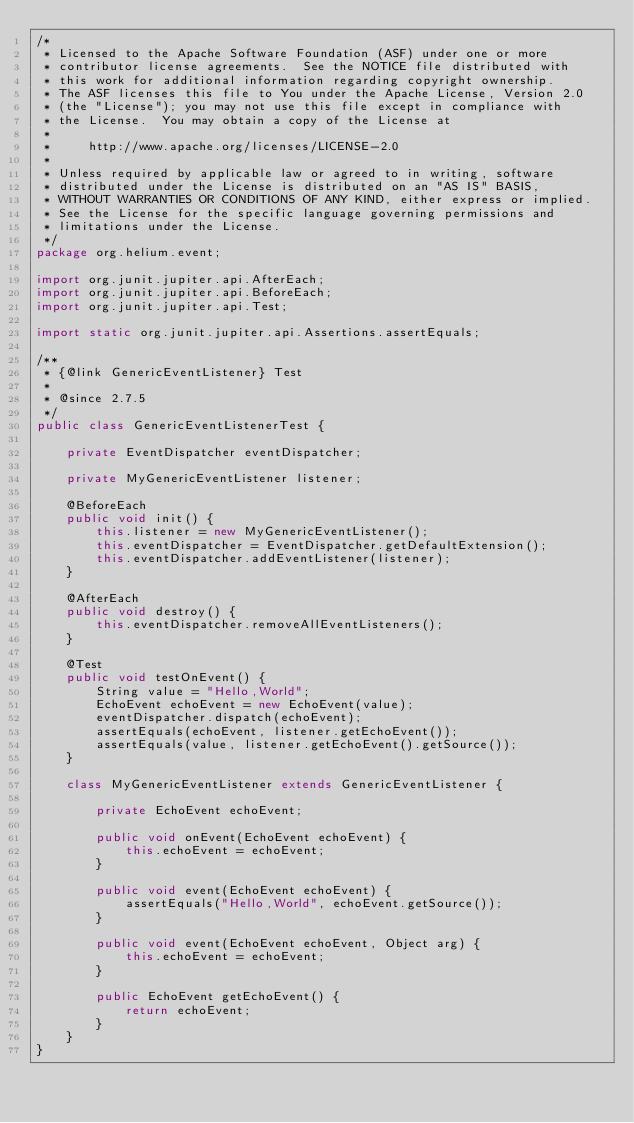Convert code to text. <code><loc_0><loc_0><loc_500><loc_500><_Java_>/*
 * Licensed to the Apache Software Foundation (ASF) under one or more
 * contributor license agreements.  See the NOTICE file distributed with
 * this work for additional information regarding copyright ownership.
 * The ASF licenses this file to You under the Apache License, Version 2.0
 * (the "License"); you may not use this file except in compliance with
 * the License.  You may obtain a copy of the License at
 *
 *     http://www.apache.org/licenses/LICENSE-2.0
 *
 * Unless required by applicable law or agreed to in writing, software
 * distributed under the License is distributed on an "AS IS" BASIS,
 * WITHOUT WARRANTIES OR CONDITIONS OF ANY KIND, either express or implied.
 * See the License for the specific language governing permissions and
 * limitations under the License.
 */
package org.helium.event;

import org.junit.jupiter.api.AfterEach;
import org.junit.jupiter.api.BeforeEach;
import org.junit.jupiter.api.Test;

import static org.junit.jupiter.api.Assertions.assertEquals;

/**
 * {@link GenericEventListener} Test
 *
 * @since 2.7.5
 */
public class GenericEventListenerTest {

    private EventDispatcher eventDispatcher;

    private MyGenericEventListener listener;

    @BeforeEach
    public void init() {
        this.listener = new MyGenericEventListener();
        this.eventDispatcher = EventDispatcher.getDefaultExtension();
        this.eventDispatcher.addEventListener(listener);
    }

    @AfterEach
    public void destroy() {
        this.eventDispatcher.removeAllEventListeners();
    }

    @Test
    public void testOnEvent() {
        String value = "Hello,World";
        EchoEvent echoEvent = new EchoEvent(value);
        eventDispatcher.dispatch(echoEvent);
        assertEquals(echoEvent, listener.getEchoEvent());
        assertEquals(value, listener.getEchoEvent().getSource());
    }

    class MyGenericEventListener extends GenericEventListener {

        private EchoEvent echoEvent;

        public void onEvent(EchoEvent echoEvent) {
            this.echoEvent = echoEvent;
        }

        public void event(EchoEvent echoEvent) {
            assertEquals("Hello,World", echoEvent.getSource());
        }

        public void event(EchoEvent echoEvent, Object arg) {
            this.echoEvent = echoEvent;
        }

        public EchoEvent getEchoEvent() {
            return echoEvent;
        }
    }
}
</code> 